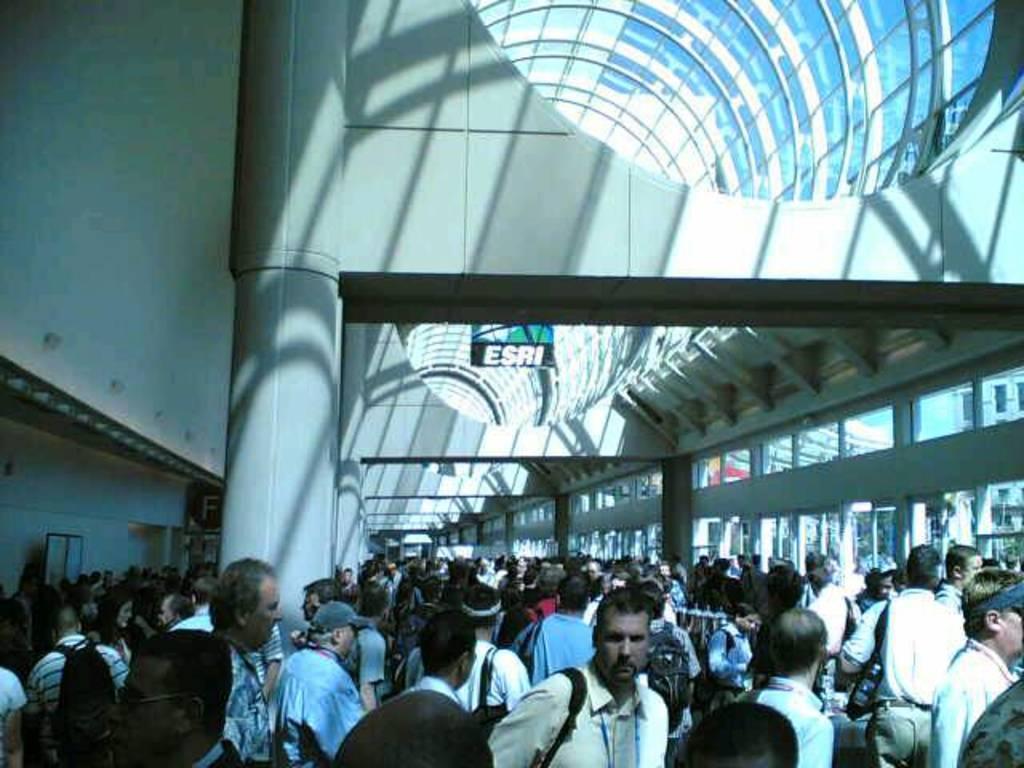Could you give a brief overview of what you see in this image? In this image there are crowd, inside a building and the building is covered with glasses. 